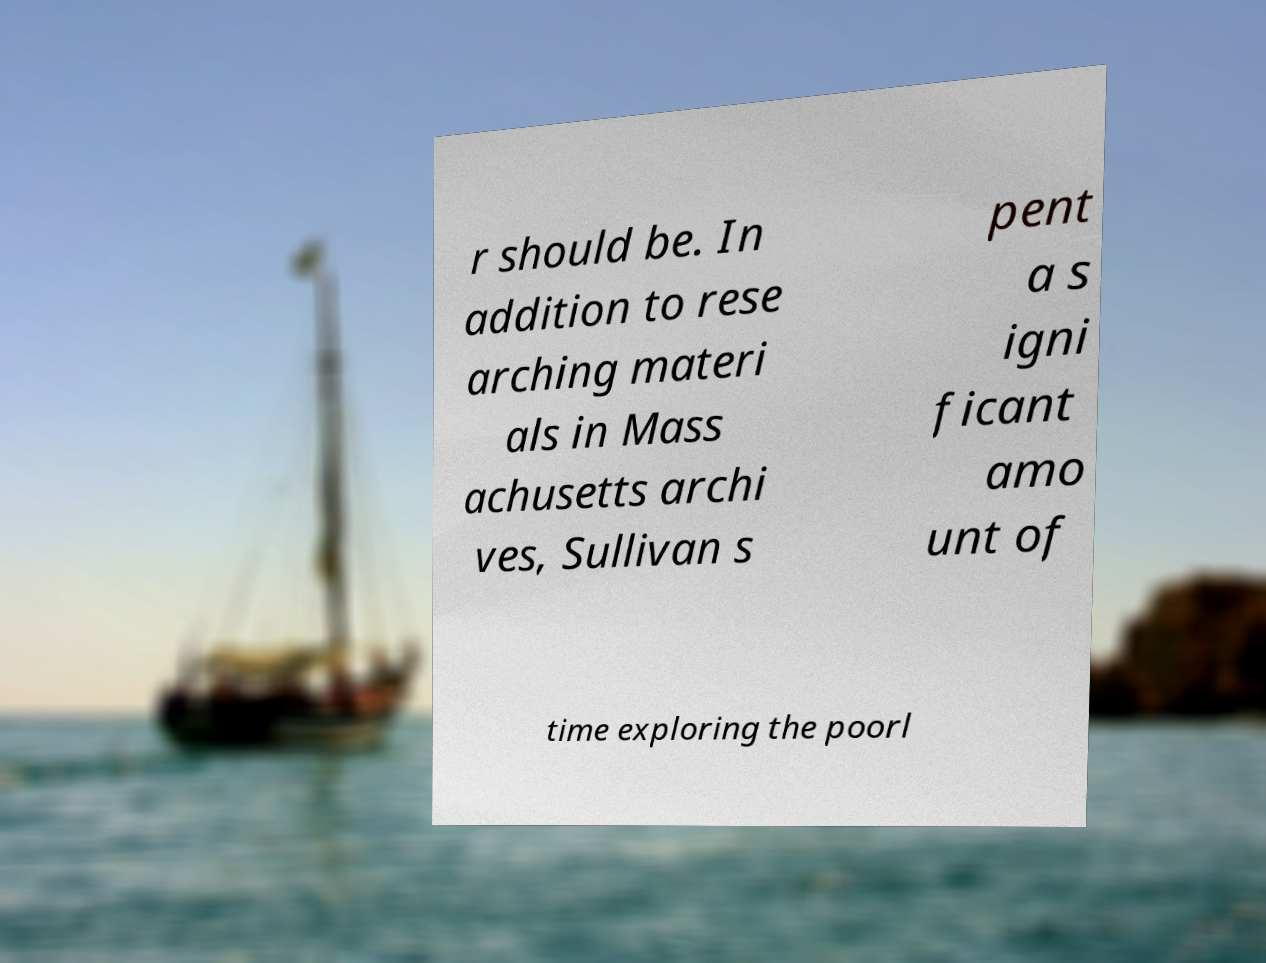Please read and relay the text visible in this image. What does it say? r should be. In addition to rese arching materi als in Mass achusetts archi ves, Sullivan s pent a s igni ficant amo unt of time exploring the poorl 